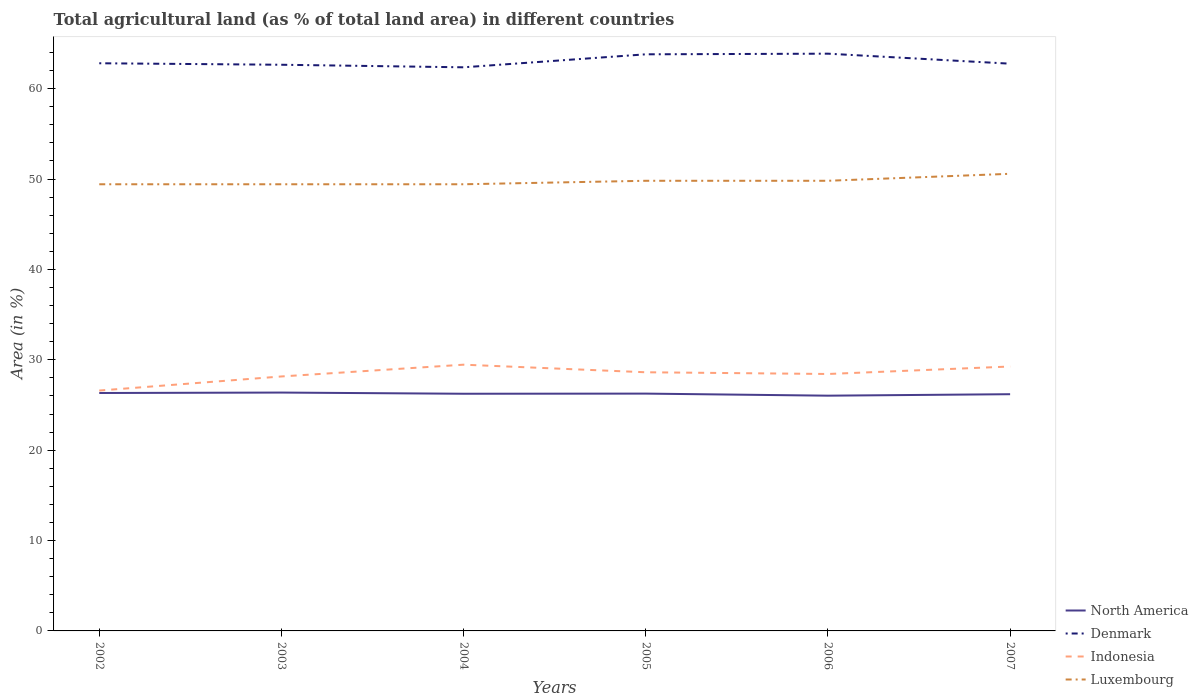Across all years, what is the maximum percentage of agricultural land in Indonesia?
Give a very brief answer. 26.6. What is the total percentage of agricultural land in Indonesia in the graph?
Your response must be concise. -1.56. What is the difference between the highest and the second highest percentage of agricultural land in Indonesia?
Provide a succinct answer. 2.86. How many years are there in the graph?
Your answer should be compact. 6. What is the difference between two consecutive major ticks on the Y-axis?
Provide a succinct answer. 10. Are the values on the major ticks of Y-axis written in scientific E-notation?
Offer a terse response. No. Does the graph contain grids?
Provide a short and direct response. No. How are the legend labels stacked?
Keep it short and to the point. Vertical. What is the title of the graph?
Keep it short and to the point. Total agricultural land (as % of total land area) in different countries. Does "Ghana" appear as one of the legend labels in the graph?
Provide a succinct answer. No. What is the label or title of the X-axis?
Keep it short and to the point. Years. What is the label or title of the Y-axis?
Offer a terse response. Area (in %). What is the Area (in %) of North America in 2002?
Your response must be concise. 26.33. What is the Area (in %) in Denmark in 2002?
Provide a succinct answer. 62.81. What is the Area (in %) in Indonesia in 2002?
Keep it short and to the point. 26.6. What is the Area (in %) of Luxembourg in 2002?
Keep it short and to the point. 49.42. What is the Area (in %) of North America in 2003?
Provide a short and direct response. 26.37. What is the Area (in %) of Denmark in 2003?
Offer a very short reply. 62.64. What is the Area (in %) in Indonesia in 2003?
Your response must be concise. 28.16. What is the Area (in %) in Luxembourg in 2003?
Your answer should be compact. 49.42. What is the Area (in %) of North America in 2004?
Your response must be concise. 26.24. What is the Area (in %) of Denmark in 2004?
Keep it short and to the point. 62.36. What is the Area (in %) of Indonesia in 2004?
Give a very brief answer. 29.46. What is the Area (in %) of Luxembourg in 2004?
Your response must be concise. 49.42. What is the Area (in %) of North America in 2005?
Keep it short and to the point. 26.26. What is the Area (in %) in Denmark in 2005?
Offer a very short reply. 63.8. What is the Area (in %) of Indonesia in 2005?
Your answer should be very brief. 28.62. What is the Area (in %) in Luxembourg in 2005?
Provide a succinct answer. 49.81. What is the Area (in %) in North America in 2006?
Offer a terse response. 26.03. What is the Area (in %) of Denmark in 2006?
Your response must be concise. 63.87. What is the Area (in %) of Indonesia in 2006?
Your answer should be very brief. 28.43. What is the Area (in %) in Luxembourg in 2006?
Your response must be concise. 49.81. What is the Area (in %) in North America in 2007?
Give a very brief answer. 26.19. What is the Area (in %) in Denmark in 2007?
Provide a short and direct response. 62.76. What is the Area (in %) in Indonesia in 2007?
Offer a very short reply. 29.26. What is the Area (in %) of Luxembourg in 2007?
Ensure brevity in your answer.  50.58. Across all years, what is the maximum Area (in %) of North America?
Give a very brief answer. 26.37. Across all years, what is the maximum Area (in %) of Denmark?
Your answer should be very brief. 63.87. Across all years, what is the maximum Area (in %) of Indonesia?
Keep it short and to the point. 29.46. Across all years, what is the maximum Area (in %) of Luxembourg?
Ensure brevity in your answer.  50.58. Across all years, what is the minimum Area (in %) in North America?
Your answer should be compact. 26.03. Across all years, what is the minimum Area (in %) of Denmark?
Make the answer very short. 62.36. Across all years, what is the minimum Area (in %) in Indonesia?
Provide a succinct answer. 26.6. Across all years, what is the minimum Area (in %) of Luxembourg?
Your answer should be compact. 49.42. What is the total Area (in %) in North America in the graph?
Your answer should be very brief. 157.42. What is the total Area (in %) in Denmark in the graph?
Your answer should be compact. 378.25. What is the total Area (in %) of Indonesia in the graph?
Your answer should be compact. 170.51. What is the total Area (in %) in Luxembourg in the graph?
Provide a short and direct response. 298.46. What is the difference between the Area (in %) of North America in 2002 and that in 2003?
Provide a short and direct response. -0.05. What is the difference between the Area (in %) of Denmark in 2002 and that in 2003?
Provide a succinct answer. 0.17. What is the difference between the Area (in %) in Indonesia in 2002 and that in 2003?
Offer a very short reply. -1.56. What is the difference between the Area (in %) in Luxembourg in 2002 and that in 2003?
Offer a terse response. 0. What is the difference between the Area (in %) of North America in 2002 and that in 2004?
Your answer should be compact. 0.08. What is the difference between the Area (in %) of Denmark in 2002 and that in 2004?
Provide a short and direct response. 0.45. What is the difference between the Area (in %) of Indonesia in 2002 and that in 2004?
Your answer should be compact. -2.86. What is the difference between the Area (in %) in North America in 2002 and that in 2005?
Make the answer very short. 0.07. What is the difference between the Area (in %) of Denmark in 2002 and that in 2005?
Your answer should be compact. -0.99. What is the difference between the Area (in %) in Indonesia in 2002 and that in 2005?
Ensure brevity in your answer.  -2.02. What is the difference between the Area (in %) in Luxembourg in 2002 and that in 2005?
Your answer should be compact. -0.39. What is the difference between the Area (in %) of North America in 2002 and that in 2006?
Provide a short and direct response. 0.3. What is the difference between the Area (in %) in Denmark in 2002 and that in 2006?
Offer a very short reply. -1.06. What is the difference between the Area (in %) of Indonesia in 2002 and that in 2006?
Your answer should be compact. -1.83. What is the difference between the Area (in %) of Luxembourg in 2002 and that in 2006?
Your answer should be very brief. -0.39. What is the difference between the Area (in %) of North America in 2002 and that in 2007?
Your answer should be compact. 0.13. What is the difference between the Area (in %) of Denmark in 2002 and that in 2007?
Your response must be concise. 0.05. What is the difference between the Area (in %) in Indonesia in 2002 and that in 2007?
Ensure brevity in your answer.  -2.66. What is the difference between the Area (in %) of Luxembourg in 2002 and that in 2007?
Your answer should be compact. -1.16. What is the difference between the Area (in %) in North America in 2003 and that in 2004?
Offer a very short reply. 0.13. What is the difference between the Area (in %) in Denmark in 2003 and that in 2004?
Ensure brevity in your answer.  0.28. What is the difference between the Area (in %) of Indonesia in 2003 and that in 2004?
Your answer should be compact. -1.3. What is the difference between the Area (in %) of Luxembourg in 2003 and that in 2004?
Provide a short and direct response. 0. What is the difference between the Area (in %) in North America in 2003 and that in 2005?
Provide a succinct answer. 0.12. What is the difference between the Area (in %) in Denmark in 2003 and that in 2005?
Offer a terse response. -1.15. What is the difference between the Area (in %) in Indonesia in 2003 and that in 2005?
Your response must be concise. -0.46. What is the difference between the Area (in %) of Luxembourg in 2003 and that in 2005?
Your answer should be very brief. -0.39. What is the difference between the Area (in %) in North America in 2003 and that in 2006?
Ensure brevity in your answer.  0.34. What is the difference between the Area (in %) of Denmark in 2003 and that in 2006?
Your answer should be compact. -1.23. What is the difference between the Area (in %) in Indonesia in 2003 and that in 2006?
Offer a very short reply. -0.27. What is the difference between the Area (in %) in Luxembourg in 2003 and that in 2006?
Give a very brief answer. -0.39. What is the difference between the Area (in %) of North America in 2003 and that in 2007?
Offer a very short reply. 0.18. What is the difference between the Area (in %) of Denmark in 2003 and that in 2007?
Your response must be concise. -0.12. What is the difference between the Area (in %) of Indonesia in 2003 and that in 2007?
Your answer should be very brief. -1.1. What is the difference between the Area (in %) in Luxembourg in 2003 and that in 2007?
Give a very brief answer. -1.16. What is the difference between the Area (in %) of North America in 2004 and that in 2005?
Your response must be concise. -0.02. What is the difference between the Area (in %) in Denmark in 2004 and that in 2005?
Provide a short and direct response. -1.44. What is the difference between the Area (in %) in Indonesia in 2004 and that in 2005?
Provide a succinct answer. 0.84. What is the difference between the Area (in %) in Luxembourg in 2004 and that in 2005?
Keep it short and to the point. -0.39. What is the difference between the Area (in %) in North America in 2004 and that in 2006?
Offer a terse response. 0.21. What is the difference between the Area (in %) of Denmark in 2004 and that in 2006?
Offer a very short reply. -1.51. What is the difference between the Area (in %) of Luxembourg in 2004 and that in 2006?
Keep it short and to the point. -0.39. What is the difference between the Area (in %) of North America in 2004 and that in 2007?
Make the answer very short. 0.05. What is the difference between the Area (in %) of Denmark in 2004 and that in 2007?
Offer a very short reply. -0.4. What is the difference between the Area (in %) in Indonesia in 2004 and that in 2007?
Keep it short and to the point. 0.2. What is the difference between the Area (in %) of Luxembourg in 2004 and that in 2007?
Your answer should be very brief. -1.16. What is the difference between the Area (in %) in North America in 2005 and that in 2006?
Offer a terse response. 0.23. What is the difference between the Area (in %) of Denmark in 2005 and that in 2006?
Your answer should be compact. -0.07. What is the difference between the Area (in %) of Indonesia in 2005 and that in 2006?
Ensure brevity in your answer.  0.19. What is the difference between the Area (in %) in North America in 2005 and that in 2007?
Your answer should be compact. 0.07. What is the difference between the Area (in %) of Denmark in 2005 and that in 2007?
Offer a very short reply. 1.04. What is the difference between the Area (in %) of Indonesia in 2005 and that in 2007?
Offer a terse response. -0.64. What is the difference between the Area (in %) in Luxembourg in 2005 and that in 2007?
Your answer should be compact. -0.77. What is the difference between the Area (in %) of North America in 2006 and that in 2007?
Ensure brevity in your answer.  -0.16. What is the difference between the Area (in %) of Denmark in 2006 and that in 2007?
Your answer should be compact. 1.11. What is the difference between the Area (in %) in Indonesia in 2006 and that in 2007?
Your response must be concise. -0.83. What is the difference between the Area (in %) of Luxembourg in 2006 and that in 2007?
Offer a very short reply. -0.77. What is the difference between the Area (in %) in North America in 2002 and the Area (in %) in Denmark in 2003?
Provide a short and direct response. -36.32. What is the difference between the Area (in %) of North America in 2002 and the Area (in %) of Indonesia in 2003?
Your response must be concise. -1.83. What is the difference between the Area (in %) of North America in 2002 and the Area (in %) of Luxembourg in 2003?
Ensure brevity in your answer.  -23.1. What is the difference between the Area (in %) in Denmark in 2002 and the Area (in %) in Indonesia in 2003?
Your response must be concise. 34.65. What is the difference between the Area (in %) of Denmark in 2002 and the Area (in %) of Luxembourg in 2003?
Offer a very short reply. 13.39. What is the difference between the Area (in %) of Indonesia in 2002 and the Area (in %) of Luxembourg in 2003?
Offer a terse response. -22.82. What is the difference between the Area (in %) of North America in 2002 and the Area (in %) of Denmark in 2004?
Your answer should be very brief. -36.04. What is the difference between the Area (in %) of North America in 2002 and the Area (in %) of Indonesia in 2004?
Your answer should be compact. -3.13. What is the difference between the Area (in %) in North America in 2002 and the Area (in %) in Luxembourg in 2004?
Provide a short and direct response. -23.1. What is the difference between the Area (in %) of Denmark in 2002 and the Area (in %) of Indonesia in 2004?
Give a very brief answer. 33.35. What is the difference between the Area (in %) in Denmark in 2002 and the Area (in %) in Luxembourg in 2004?
Ensure brevity in your answer.  13.39. What is the difference between the Area (in %) of Indonesia in 2002 and the Area (in %) of Luxembourg in 2004?
Provide a succinct answer. -22.82. What is the difference between the Area (in %) of North America in 2002 and the Area (in %) of Denmark in 2005?
Provide a succinct answer. -37.47. What is the difference between the Area (in %) in North America in 2002 and the Area (in %) in Indonesia in 2005?
Ensure brevity in your answer.  -2.29. What is the difference between the Area (in %) in North America in 2002 and the Area (in %) in Luxembourg in 2005?
Give a very brief answer. -23.48. What is the difference between the Area (in %) of Denmark in 2002 and the Area (in %) of Indonesia in 2005?
Offer a terse response. 34.19. What is the difference between the Area (in %) in Denmark in 2002 and the Area (in %) in Luxembourg in 2005?
Provide a short and direct response. 13. What is the difference between the Area (in %) of Indonesia in 2002 and the Area (in %) of Luxembourg in 2005?
Your answer should be compact. -23.21. What is the difference between the Area (in %) in North America in 2002 and the Area (in %) in Denmark in 2006?
Ensure brevity in your answer.  -37.54. What is the difference between the Area (in %) in North America in 2002 and the Area (in %) in Indonesia in 2006?
Ensure brevity in your answer.  -2.1. What is the difference between the Area (in %) of North America in 2002 and the Area (in %) of Luxembourg in 2006?
Make the answer very short. -23.48. What is the difference between the Area (in %) in Denmark in 2002 and the Area (in %) in Indonesia in 2006?
Give a very brief answer. 34.38. What is the difference between the Area (in %) in Denmark in 2002 and the Area (in %) in Luxembourg in 2006?
Make the answer very short. 13. What is the difference between the Area (in %) in Indonesia in 2002 and the Area (in %) in Luxembourg in 2006?
Make the answer very short. -23.21. What is the difference between the Area (in %) of North America in 2002 and the Area (in %) of Denmark in 2007?
Your response must be concise. -36.44. What is the difference between the Area (in %) of North America in 2002 and the Area (in %) of Indonesia in 2007?
Your response must be concise. -2.93. What is the difference between the Area (in %) of North America in 2002 and the Area (in %) of Luxembourg in 2007?
Your answer should be very brief. -24.25. What is the difference between the Area (in %) of Denmark in 2002 and the Area (in %) of Indonesia in 2007?
Make the answer very short. 33.55. What is the difference between the Area (in %) of Denmark in 2002 and the Area (in %) of Luxembourg in 2007?
Ensure brevity in your answer.  12.23. What is the difference between the Area (in %) in Indonesia in 2002 and the Area (in %) in Luxembourg in 2007?
Offer a terse response. -23.98. What is the difference between the Area (in %) of North America in 2003 and the Area (in %) of Denmark in 2004?
Your answer should be very brief. -35.99. What is the difference between the Area (in %) of North America in 2003 and the Area (in %) of Indonesia in 2004?
Offer a very short reply. -3.08. What is the difference between the Area (in %) of North America in 2003 and the Area (in %) of Luxembourg in 2004?
Make the answer very short. -23.05. What is the difference between the Area (in %) of Denmark in 2003 and the Area (in %) of Indonesia in 2004?
Your answer should be compact. 33.19. What is the difference between the Area (in %) of Denmark in 2003 and the Area (in %) of Luxembourg in 2004?
Your answer should be compact. 13.22. What is the difference between the Area (in %) in Indonesia in 2003 and the Area (in %) in Luxembourg in 2004?
Make the answer very short. -21.27. What is the difference between the Area (in %) in North America in 2003 and the Area (in %) in Denmark in 2005?
Your answer should be very brief. -37.43. What is the difference between the Area (in %) in North America in 2003 and the Area (in %) in Indonesia in 2005?
Your response must be concise. -2.25. What is the difference between the Area (in %) of North America in 2003 and the Area (in %) of Luxembourg in 2005?
Your answer should be very brief. -23.43. What is the difference between the Area (in %) in Denmark in 2003 and the Area (in %) in Indonesia in 2005?
Keep it short and to the point. 34.02. What is the difference between the Area (in %) of Denmark in 2003 and the Area (in %) of Luxembourg in 2005?
Your answer should be very brief. 12.84. What is the difference between the Area (in %) in Indonesia in 2003 and the Area (in %) in Luxembourg in 2005?
Keep it short and to the point. -21.65. What is the difference between the Area (in %) of North America in 2003 and the Area (in %) of Denmark in 2006?
Give a very brief answer. -37.5. What is the difference between the Area (in %) in North America in 2003 and the Area (in %) in Indonesia in 2006?
Provide a succinct answer. -2.05. What is the difference between the Area (in %) in North America in 2003 and the Area (in %) in Luxembourg in 2006?
Provide a short and direct response. -23.43. What is the difference between the Area (in %) in Denmark in 2003 and the Area (in %) in Indonesia in 2006?
Keep it short and to the point. 34.22. What is the difference between the Area (in %) of Denmark in 2003 and the Area (in %) of Luxembourg in 2006?
Your answer should be very brief. 12.84. What is the difference between the Area (in %) of Indonesia in 2003 and the Area (in %) of Luxembourg in 2006?
Provide a succinct answer. -21.65. What is the difference between the Area (in %) in North America in 2003 and the Area (in %) in Denmark in 2007?
Make the answer very short. -36.39. What is the difference between the Area (in %) of North America in 2003 and the Area (in %) of Indonesia in 2007?
Ensure brevity in your answer.  -2.88. What is the difference between the Area (in %) of North America in 2003 and the Area (in %) of Luxembourg in 2007?
Offer a very short reply. -24.21. What is the difference between the Area (in %) of Denmark in 2003 and the Area (in %) of Indonesia in 2007?
Make the answer very short. 33.39. What is the difference between the Area (in %) in Denmark in 2003 and the Area (in %) in Luxembourg in 2007?
Your answer should be compact. 12.07. What is the difference between the Area (in %) of Indonesia in 2003 and the Area (in %) of Luxembourg in 2007?
Keep it short and to the point. -22.42. What is the difference between the Area (in %) in North America in 2004 and the Area (in %) in Denmark in 2005?
Offer a terse response. -37.56. What is the difference between the Area (in %) in North America in 2004 and the Area (in %) in Indonesia in 2005?
Offer a very short reply. -2.38. What is the difference between the Area (in %) in North America in 2004 and the Area (in %) in Luxembourg in 2005?
Offer a terse response. -23.56. What is the difference between the Area (in %) in Denmark in 2004 and the Area (in %) in Indonesia in 2005?
Your answer should be compact. 33.74. What is the difference between the Area (in %) in Denmark in 2004 and the Area (in %) in Luxembourg in 2005?
Give a very brief answer. 12.55. What is the difference between the Area (in %) in Indonesia in 2004 and the Area (in %) in Luxembourg in 2005?
Your response must be concise. -20.35. What is the difference between the Area (in %) of North America in 2004 and the Area (in %) of Denmark in 2006?
Your answer should be very brief. -37.63. What is the difference between the Area (in %) in North America in 2004 and the Area (in %) in Indonesia in 2006?
Keep it short and to the point. -2.19. What is the difference between the Area (in %) in North America in 2004 and the Area (in %) in Luxembourg in 2006?
Keep it short and to the point. -23.56. What is the difference between the Area (in %) of Denmark in 2004 and the Area (in %) of Indonesia in 2006?
Your answer should be compact. 33.93. What is the difference between the Area (in %) of Denmark in 2004 and the Area (in %) of Luxembourg in 2006?
Give a very brief answer. 12.55. What is the difference between the Area (in %) of Indonesia in 2004 and the Area (in %) of Luxembourg in 2006?
Your response must be concise. -20.35. What is the difference between the Area (in %) of North America in 2004 and the Area (in %) of Denmark in 2007?
Give a very brief answer. -36.52. What is the difference between the Area (in %) of North America in 2004 and the Area (in %) of Indonesia in 2007?
Give a very brief answer. -3.01. What is the difference between the Area (in %) in North America in 2004 and the Area (in %) in Luxembourg in 2007?
Give a very brief answer. -24.34. What is the difference between the Area (in %) of Denmark in 2004 and the Area (in %) of Indonesia in 2007?
Ensure brevity in your answer.  33.11. What is the difference between the Area (in %) of Denmark in 2004 and the Area (in %) of Luxembourg in 2007?
Your response must be concise. 11.78. What is the difference between the Area (in %) in Indonesia in 2004 and the Area (in %) in Luxembourg in 2007?
Keep it short and to the point. -21.12. What is the difference between the Area (in %) of North America in 2005 and the Area (in %) of Denmark in 2006?
Ensure brevity in your answer.  -37.61. What is the difference between the Area (in %) in North America in 2005 and the Area (in %) in Indonesia in 2006?
Your response must be concise. -2.17. What is the difference between the Area (in %) of North America in 2005 and the Area (in %) of Luxembourg in 2006?
Offer a terse response. -23.55. What is the difference between the Area (in %) in Denmark in 2005 and the Area (in %) in Indonesia in 2006?
Your answer should be very brief. 35.37. What is the difference between the Area (in %) in Denmark in 2005 and the Area (in %) in Luxembourg in 2006?
Your answer should be very brief. 13.99. What is the difference between the Area (in %) of Indonesia in 2005 and the Area (in %) of Luxembourg in 2006?
Provide a short and direct response. -21.19. What is the difference between the Area (in %) in North America in 2005 and the Area (in %) in Denmark in 2007?
Your answer should be compact. -36.5. What is the difference between the Area (in %) in North America in 2005 and the Area (in %) in Indonesia in 2007?
Ensure brevity in your answer.  -3. What is the difference between the Area (in %) in North America in 2005 and the Area (in %) in Luxembourg in 2007?
Provide a short and direct response. -24.32. What is the difference between the Area (in %) in Denmark in 2005 and the Area (in %) in Indonesia in 2007?
Make the answer very short. 34.54. What is the difference between the Area (in %) in Denmark in 2005 and the Area (in %) in Luxembourg in 2007?
Your answer should be compact. 13.22. What is the difference between the Area (in %) in Indonesia in 2005 and the Area (in %) in Luxembourg in 2007?
Give a very brief answer. -21.96. What is the difference between the Area (in %) in North America in 2006 and the Area (in %) in Denmark in 2007?
Provide a short and direct response. -36.73. What is the difference between the Area (in %) in North America in 2006 and the Area (in %) in Indonesia in 2007?
Provide a succinct answer. -3.23. What is the difference between the Area (in %) in North America in 2006 and the Area (in %) in Luxembourg in 2007?
Provide a short and direct response. -24.55. What is the difference between the Area (in %) of Denmark in 2006 and the Area (in %) of Indonesia in 2007?
Offer a terse response. 34.61. What is the difference between the Area (in %) in Denmark in 2006 and the Area (in %) in Luxembourg in 2007?
Ensure brevity in your answer.  13.29. What is the difference between the Area (in %) in Indonesia in 2006 and the Area (in %) in Luxembourg in 2007?
Make the answer very short. -22.15. What is the average Area (in %) of North America per year?
Your answer should be compact. 26.24. What is the average Area (in %) of Denmark per year?
Give a very brief answer. 63.04. What is the average Area (in %) in Indonesia per year?
Your answer should be compact. 28.42. What is the average Area (in %) in Luxembourg per year?
Provide a succinct answer. 49.74. In the year 2002, what is the difference between the Area (in %) of North America and Area (in %) of Denmark?
Provide a short and direct response. -36.48. In the year 2002, what is the difference between the Area (in %) in North America and Area (in %) in Indonesia?
Give a very brief answer. -0.27. In the year 2002, what is the difference between the Area (in %) in North America and Area (in %) in Luxembourg?
Your response must be concise. -23.1. In the year 2002, what is the difference between the Area (in %) in Denmark and Area (in %) in Indonesia?
Make the answer very short. 36.21. In the year 2002, what is the difference between the Area (in %) in Denmark and Area (in %) in Luxembourg?
Your answer should be compact. 13.39. In the year 2002, what is the difference between the Area (in %) of Indonesia and Area (in %) of Luxembourg?
Offer a terse response. -22.82. In the year 2003, what is the difference between the Area (in %) of North America and Area (in %) of Denmark?
Offer a very short reply. -36.27. In the year 2003, what is the difference between the Area (in %) in North America and Area (in %) in Indonesia?
Your answer should be compact. -1.78. In the year 2003, what is the difference between the Area (in %) in North America and Area (in %) in Luxembourg?
Keep it short and to the point. -23.05. In the year 2003, what is the difference between the Area (in %) of Denmark and Area (in %) of Indonesia?
Ensure brevity in your answer.  34.49. In the year 2003, what is the difference between the Area (in %) of Denmark and Area (in %) of Luxembourg?
Ensure brevity in your answer.  13.22. In the year 2003, what is the difference between the Area (in %) of Indonesia and Area (in %) of Luxembourg?
Provide a succinct answer. -21.27. In the year 2004, what is the difference between the Area (in %) in North America and Area (in %) in Denmark?
Ensure brevity in your answer.  -36.12. In the year 2004, what is the difference between the Area (in %) of North America and Area (in %) of Indonesia?
Provide a succinct answer. -3.22. In the year 2004, what is the difference between the Area (in %) of North America and Area (in %) of Luxembourg?
Your answer should be very brief. -23.18. In the year 2004, what is the difference between the Area (in %) of Denmark and Area (in %) of Indonesia?
Ensure brevity in your answer.  32.9. In the year 2004, what is the difference between the Area (in %) of Denmark and Area (in %) of Luxembourg?
Give a very brief answer. 12.94. In the year 2004, what is the difference between the Area (in %) in Indonesia and Area (in %) in Luxembourg?
Offer a terse response. -19.96. In the year 2005, what is the difference between the Area (in %) in North America and Area (in %) in Denmark?
Your response must be concise. -37.54. In the year 2005, what is the difference between the Area (in %) of North America and Area (in %) of Indonesia?
Your answer should be compact. -2.36. In the year 2005, what is the difference between the Area (in %) of North America and Area (in %) of Luxembourg?
Offer a very short reply. -23.55. In the year 2005, what is the difference between the Area (in %) in Denmark and Area (in %) in Indonesia?
Make the answer very short. 35.18. In the year 2005, what is the difference between the Area (in %) of Denmark and Area (in %) of Luxembourg?
Provide a succinct answer. 13.99. In the year 2005, what is the difference between the Area (in %) in Indonesia and Area (in %) in Luxembourg?
Provide a short and direct response. -21.19. In the year 2006, what is the difference between the Area (in %) in North America and Area (in %) in Denmark?
Keep it short and to the point. -37.84. In the year 2006, what is the difference between the Area (in %) in North America and Area (in %) in Indonesia?
Offer a very short reply. -2.4. In the year 2006, what is the difference between the Area (in %) of North America and Area (in %) of Luxembourg?
Give a very brief answer. -23.78. In the year 2006, what is the difference between the Area (in %) in Denmark and Area (in %) in Indonesia?
Provide a succinct answer. 35.44. In the year 2006, what is the difference between the Area (in %) in Denmark and Area (in %) in Luxembourg?
Keep it short and to the point. 14.06. In the year 2006, what is the difference between the Area (in %) of Indonesia and Area (in %) of Luxembourg?
Your response must be concise. -21.38. In the year 2007, what is the difference between the Area (in %) of North America and Area (in %) of Denmark?
Your answer should be very brief. -36.57. In the year 2007, what is the difference between the Area (in %) of North America and Area (in %) of Indonesia?
Ensure brevity in your answer.  -3.06. In the year 2007, what is the difference between the Area (in %) in North America and Area (in %) in Luxembourg?
Your response must be concise. -24.39. In the year 2007, what is the difference between the Area (in %) in Denmark and Area (in %) in Indonesia?
Provide a short and direct response. 33.51. In the year 2007, what is the difference between the Area (in %) in Denmark and Area (in %) in Luxembourg?
Offer a terse response. 12.18. In the year 2007, what is the difference between the Area (in %) of Indonesia and Area (in %) of Luxembourg?
Keep it short and to the point. -21.32. What is the ratio of the Area (in %) of Denmark in 2002 to that in 2003?
Keep it short and to the point. 1. What is the ratio of the Area (in %) in Indonesia in 2002 to that in 2003?
Keep it short and to the point. 0.94. What is the ratio of the Area (in %) of Luxembourg in 2002 to that in 2003?
Make the answer very short. 1. What is the ratio of the Area (in %) in North America in 2002 to that in 2004?
Your answer should be compact. 1. What is the ratio of the Area (in %) in Indonesia in 2002 to that in 2004?
Your answer should be very brief. 0.9. What is the ratio of the Area (in %) in North America in 2002 to that in 2005?
Keep it short and to the point. 1. What is the ratio of the Area (in %) of Denmark in 2002 to that in 2005?
Keep it short and to the point. 0.98. What is the ratio of the Area (in %) in Indonesia in 2002 to that in 2005?
Provide a succinct answer. 0.93. What is the ratio of the Area (in %) of North America in 2002 to that in 2006?
Offer a very short reply. 1.01. What is the ratio of the Area (in %) of Denmark in 2002 to that in 2006?
Keep it short and to the point. 0.98. What is the ratio of the Area (in %) of Indonesia in 2002 to that in 2006?
Offer a terse response. 0.94. What is the ratio of the Area (in %) of Luxembourg in 2002 to that in 2006?
Keep it short and to the point. 0.99. What is the ratio of the Area (in %) of North America in 2002 to that in 2007?
Your answer should be compact. 1.01. What is the ratio of the Area (in %) of Indonesia in 2002 to that in 2007?
Keep it short and to the point. 0.91. What is the ratio of the Area (in %) of Luxembourg in 2002 to that in 2007?
Your answer should be very brief. 0.98. What is the ratio of the Area (in %) in Indonesia in 2003 to that in 2004?
Offer a very short reply. 0.96. What is the ratio of the Area (in %) in Denmark in 2003 to that in 2005?
Provide a short and direct response. 0.98. What is the ratio of the Area (in %) in Indonesia in 2003 to that in 2005?
Give a very brief answer. 0.98. What is the ratio of the Area (in %) in Luxembourg in 2003 to that in 2005?
Provide a succinct answer. 0.99. What is the ratio of the Area (in %) in North America in 2003 to that in 2006?
Your answer should be compact. 1.01. What is the ratio of the Area (in %) of Denmark in 2003 to that in 2006?
Your answer should be compact. 0.98. What is the ratio of the Area (in %) in Indonesia in 2003 to that in 2007?
Your answer should be compact. 0.96. What is the ratio of the Area (in %) in Luxembourg in 2003 to that in 2007?
Make the answer very short. 0.98. What is the ratio of the Area (in %) in Denmark in 2004 to that in 2005?
Provide a succinct answer. 0.98. What is the ratio of the Area (in %) in Indonesia in 2004 to that in 2005?
Make the answer very short. 1.03. What is the ratio of the Area (in %) of Luxembourg in 2004 to that in 2005?
Offer a very short reply. 0.99. What is the ratio of the Area (in %) in North America in 2004 to that in 2006?
Keep it short and to the point. 1.01. What is the ratio of the Area (in %) in Denmark in 2004 to that in 2006?
Provide a succinct answer. 0.98. What is the ratio of the Area (in %) of Indonesia in 2004 to that in 2006?
Offer a very short reply. 1.04. What is the ratio of the Area (in %) of North America in 2004 to that in 2007?
Keep it short and to the point. 1. What is the ratio of the Area (in %) of Indonesia in 2004 to that in 2007?
Make the answer very short. 1.01. What is the ratio of the Area (in %) in Luxembourg in 2004 to that in 2007?
Keep it short and to the point. 0.98. What is the ratio of the Area (in %) of North America in 2005 to that in 2006?
Your answer should be very brief. 1.01. What is the ratio of the Area (in %) in Denmark in 2005 to that in 2006?
Your answer should be very brief. 1. What is the ratio of the Area (in %) of Indonesia in 2005 to that in 2006?
Keep it short and to the point. 1.01. What is the ratio of the Area (in %) of Denmark in 2005 to that in 2007?
Offer a very short reply. 1.02. What is the ratio of the Area (in %) in Indonesia in 2005 to that in 2007?
Make the answer very short. 0.98. What is the ratio of the Area (in %) in Luxembourg in 2005 to that in 2007?
Make the answer very short. 0.98. What is the ratio of the Area (in %) of Denmark in 2006 to that in 2007?
Make the answer very short. 1.02. What is the ratio of the Area (in %) of Indonesia in 2006 to that in 2007?
Make the answer very short. 0.97. What is the ratio of the Area (in %) of Luxembourg in 2006 to that in 2007?
Your answer should be very brief. 0.98. What is the difference between the highest and the second highest Area (in %) in North America?
Give a very brief answer. 0.05. What is the difference between the highest and the second highest Area (in %) of Denmark?
Offer a terse response. 0.07. What is the difference between the highest and the second highest Area (in %) of Indonesia?
Provide a succinct answer. 0.2. What is the difference between the highest and the second highest Area (in %) of Luxembourg?
Give a very brief answer. 0.77. What is the difference between the highest and the lowest Area (in %) of North America?
Offer a very short reply. 0.34. What is the difference between the highest and the lowest Area (in %) in Denmark?
Offer a terse response. 1.51. What is the difference between the highest and the lowest Area (in %) in Indonesia?
Offer a terse response. 2.86. What is the difference between the highest and the lowest Area (in %) in Luxembourg?
Offer a very short reply. 1.16. 